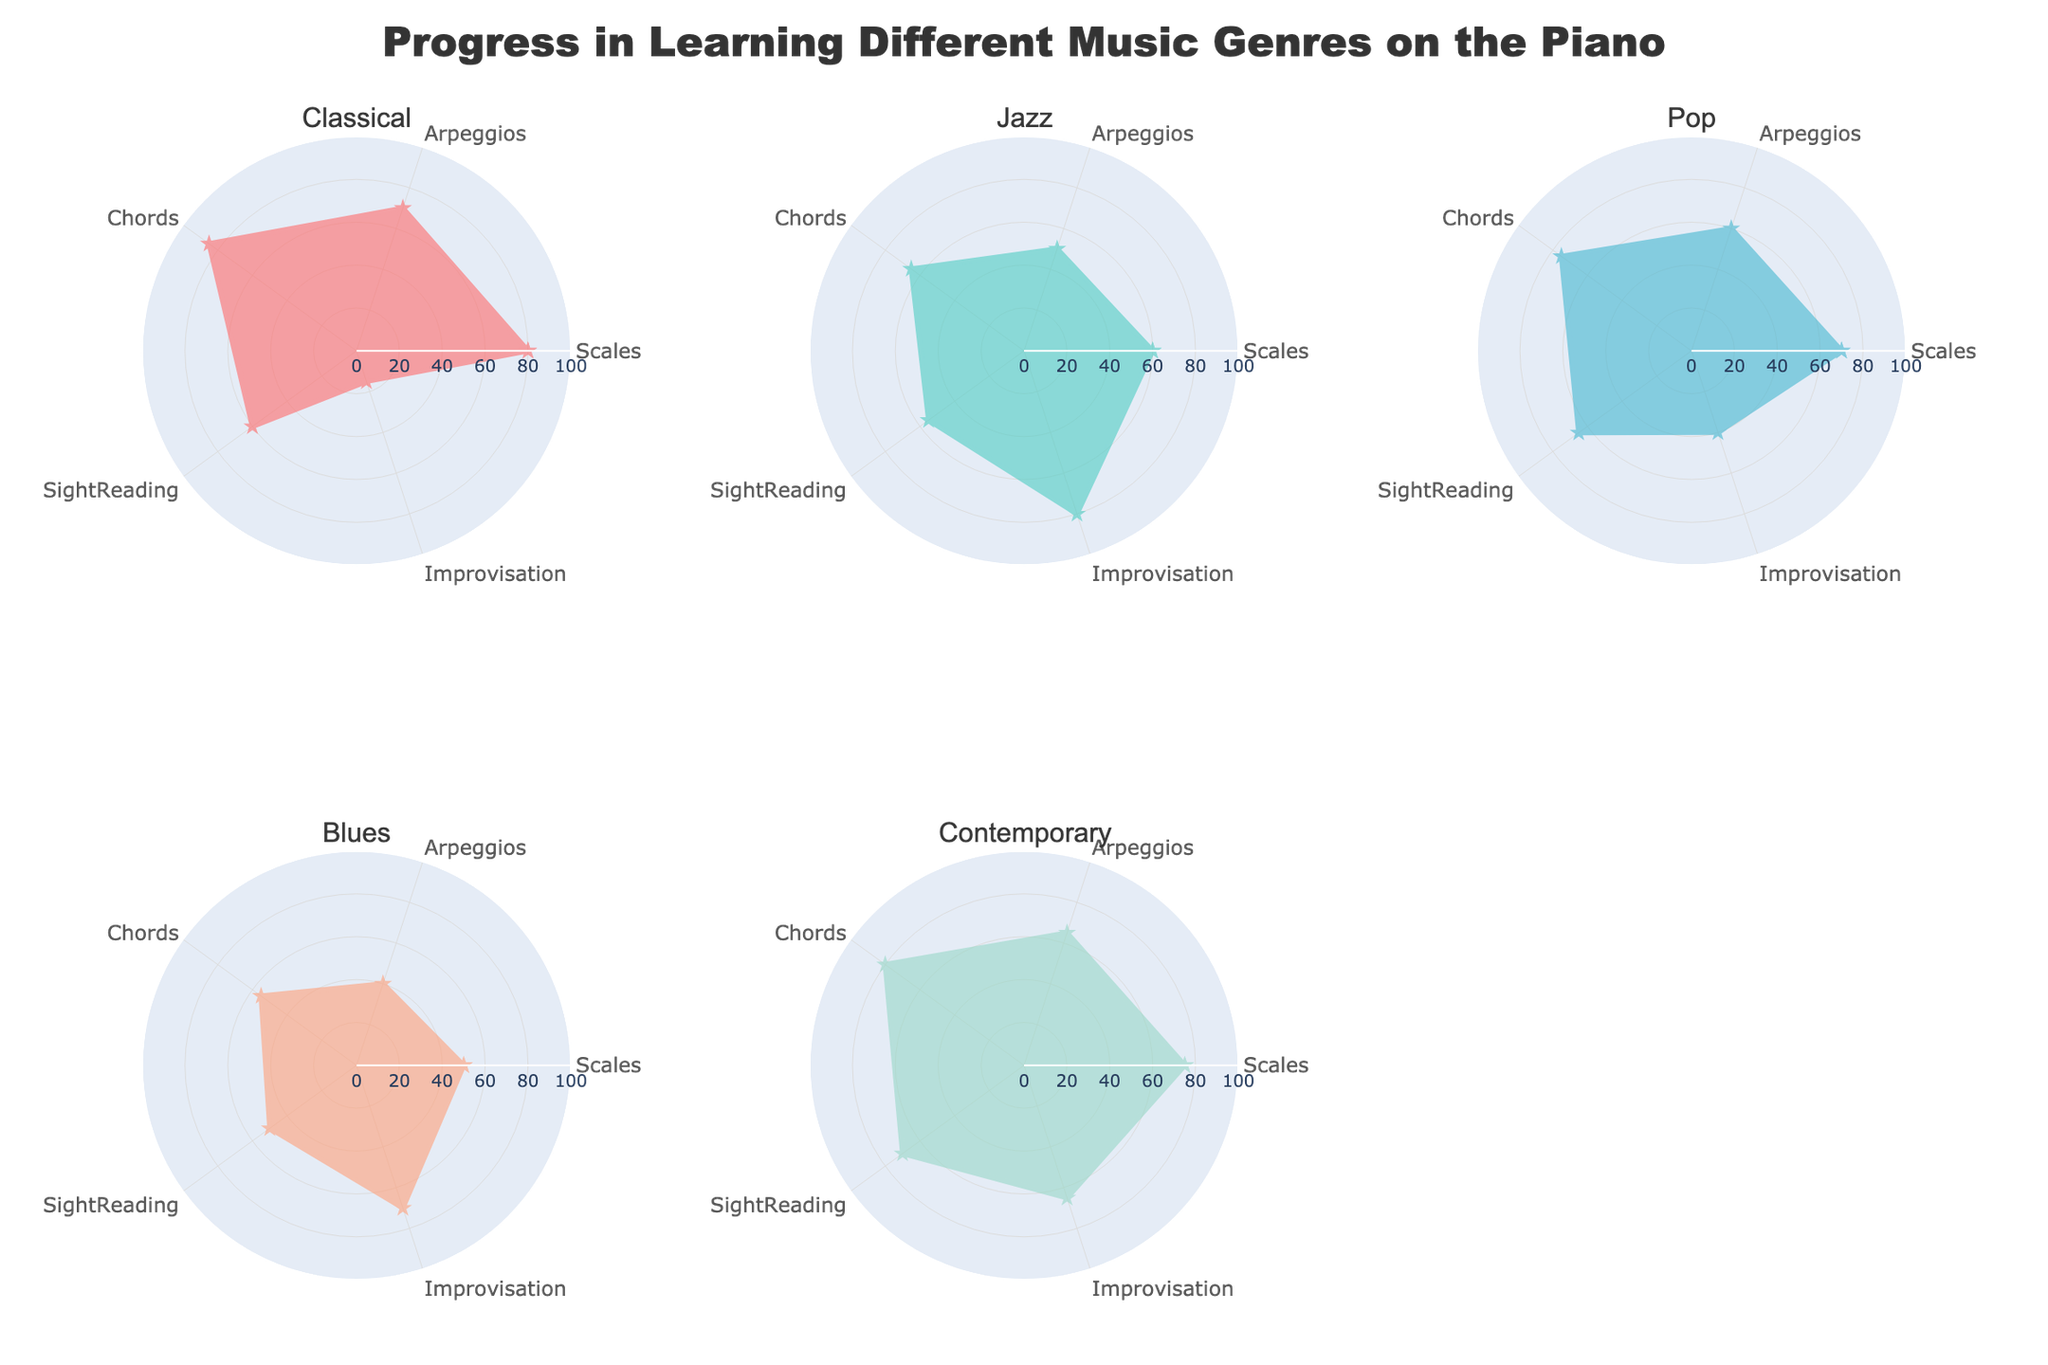what is the highest score achieved in 'Improvisation'? By examining the radar chart, the highest score for 'Improvisation' appears as the furthest point on the corresponding axis. Jazz has the highest score in 'Improvisation'.
Answer: Jazz which genre has the lowest score in 'Scales'? By looking at the radar chart, the genre with the least extension in the 'Scales' axis has the lowest score. Blues has the lowest score of 50 in 'Scales'.
Answer: Blues what is the average score of 'SightReading' across all genres? Calculate the sum of the 'SightReading' scores across all genres (60 + 55 + 65 + 50 + 70) and then divide by the number of genres (5). So, (60+55+65+50+70) / 5 = 60.
Answer: 60 how does Contemporary compare to Pop in terms of 'Chords'? Compare the 'Chords' scores for both genres. Contemporary has a score of 80, while Pop has a score of 75, so Contemporary has a higher 'Chords' score.
Answer: Contemporary scores higher which genre has the most consistent scores across the features? The genre with scores that are more evenly distributed and less variation is the most consistent. Classical ranges from 15 to 85, Jazz from 50 to 80, Pop from 60 to 75, Blues from 40 to 70, and Contemporary from 65 to 80. Contemporary has the smallest range and is the most consistent.
Answer: Contemporary which genre's radar plot covers the largest area? The areas covered can be visually estimated by looking at the overall spread of the radar plot. A more expanded and evenly spread plot covers a larger area. Classical's plot appears to cover the largest area.
Answer: Classical what is the difference in 'Chords' scores between Blues and Pop? Subtract Blues' 'Chords' score from Pop's 'Chords' score, i.e., 75 - 55 = 20.
Answer: 20 is there any genre that has its highest score in 'SightReading'? Check the highest score in 'SightReading' for each genre and compare it with their other scores. No genre has its highest score at 'SightReading'.
Answer: No 